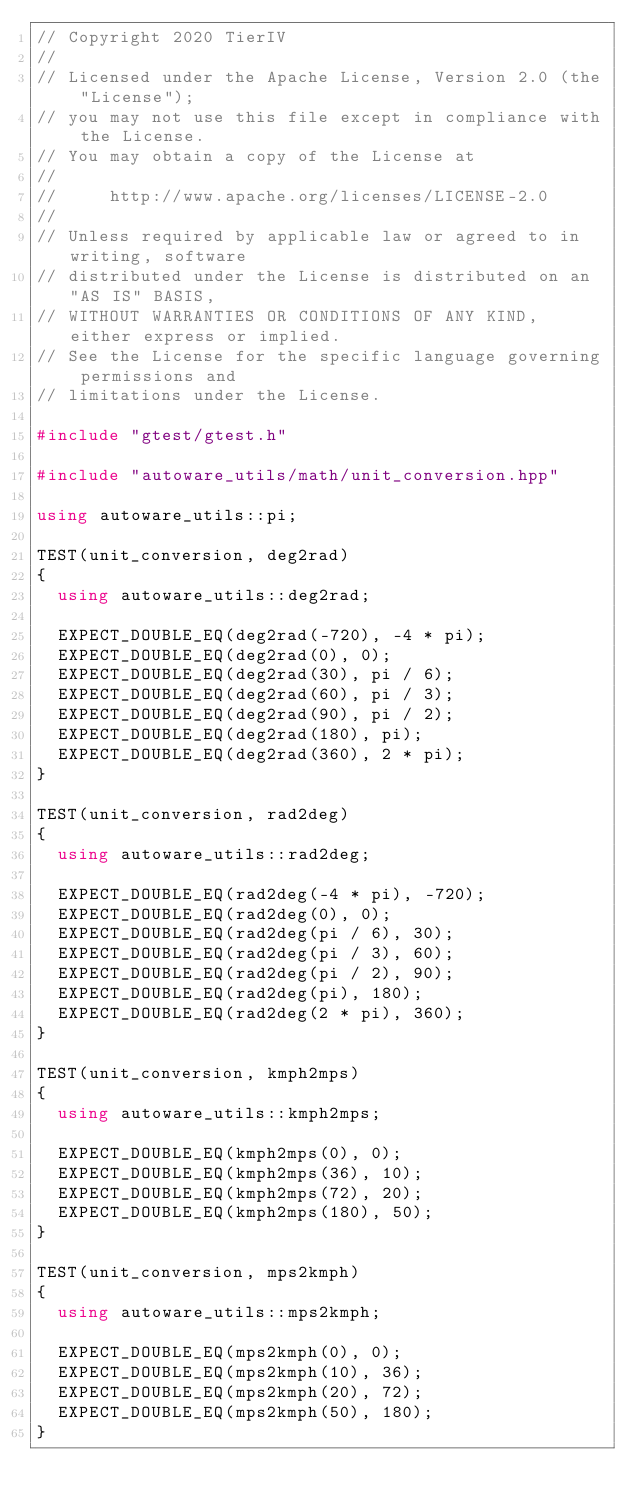<code> <loc_0><loc_0><loc_500><loc_500><_C++_>// Copyright 2020 TierIV
//
// Licensed under the Apache License, Version 2.0 (the "License");
// you may not use this file except in compliance with the License.
// You may obtain a copy of the License at
//
//     http://www.apache.org/licenses/LICENSE-2.0
//
// Unless required by applicable law or agreed to in writing, software
// distributed under the License is distributed on an "AS IS" BASIS,
// WITHOUT WARRANTIES OR CONDITIONS OF ANY KIND, either express or implied.
// See the License for the specific language governing permissions and
// limitations under the License.

#include "gtest/gtest.h"

#include "autoware_utils/math/unit_conversion.hpp"

using autoware_utils::pi;

TEST(unit_conversion, deg2rad)
{
  using autoware_utils::deg2rad;

  EXPECT_DOUBLE_EQ(deg2rad(-720), -4 * pi);
  EXPECT_DOUBLE_EQ(deg2rad(0), 0);
  EXPECT_DOUBLE_EQ(deg2rad(30), pi / 6);
  EXPECT_DOUBLE_EQ(deg2rad(60), pi / 3);
  EXPECT_DOUBLE_EQ(deg2rad(90), pi / 2);
  EXPECT_DOUBLE_EQ(deg2rad(180), pi);
  EXPECT_DOUBLE_EQ(deg2rad(360), 2 * pi);
}

TEST(unit_conversion, rad2deg)
{
  using autoware_utils::rad2deg;

  EXPECT_DOUBLE_EQ(rad2deg(-4 * pi), -720);
  EXPECT_DOUBLE_EQ(rad2deg(0), 0);
  EXPECT_DOUBLE_EQ(rad2deg(pi / 6), 30);
  EXPECT_DOUBLE_EQ(rad2deg(pi / 3), 60);
  EXPECT_DOUBLE_EQ(rad2deg(pi / 2), 90);
  EXPECT_DOUBLE_EQ(rad2deg(pi), 180);
  EXPECT_DOUBLE_EQ(rad2deg(2 * pi), 360);
}

TEST(unit_conversion, kmph2mps)
{
  using autoware_utils::kmph2mps;

  EXPECT_DOUBLE_EQ(kmph2mps(0), 0);
  EXPECT_DOUBLE_EQ(kmph2mps(36), 10);
  EXPECT_DOUBLE_EQ(kmph2mps(72), 20);
  EXPECT_DOUBLE_EQ(kmph2mps(180), 50);
}

TEST(unit_conversion, mps2kmph)
{
  using autoware_utils::mps2kmph;

  EXPECT_DOUBLE_EQ(mps2kmph(0), 0);
  EXPECT_DOUBLE_EQ(mps2kmph(10), 36);
  EXPECT_DOUBLE_EQ(mps2kmph(20), 72);
  EXPECT_DOUBLE_EQ(mps2kmph(50), 180);
}
</code> 